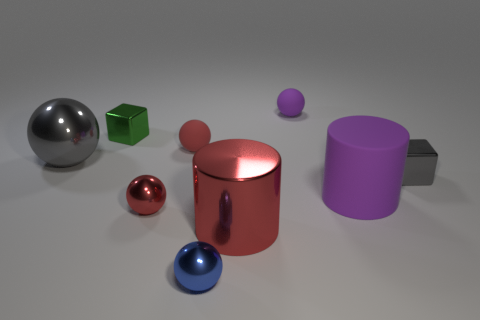There is a small object that is the same color as the large shiny ball; what shape is it?
Offer a terse response. Cube. There is a shiny thing that is right of the tiny purple rubber object; what size is it?
Give a very brief answer. Small. There is a red object that is to the right of the blue sphere; is there a shiny sphere that is behind it?
Keep it short and to the point. Yes. Does the purple thing that is to the left of the large purple cylinder have the same material as the small gray block?
Keep it short and to the point. No. What number of metallic things are left of the big purple matte object and right of the small blue metal ball?
Provide a succinct answer. 1. What number of other blue spheres are the same material as the tiny blue ball?
Your response must be concise. 0. What color is the large cylinder that is the same material as the small gray object?
Give a very brief answer. Red. Are there fewer tiny gray metal blocks than small red things?
Make the answer very short. Yes. What material is the big object that is on the right side of the rubber sphere that is behind the tiny metallic block to the left of the tiny blue metal ball made of?
Make the answer very short. Rubber. What is the large purple thing made of?
Offer a terse response. Rubber. 